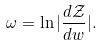<formula> <loc_0><loc_0><loc_500><loc_500>\omega = \ln | \frac { d \mathcal { Z } } { d w } | .</formula> 